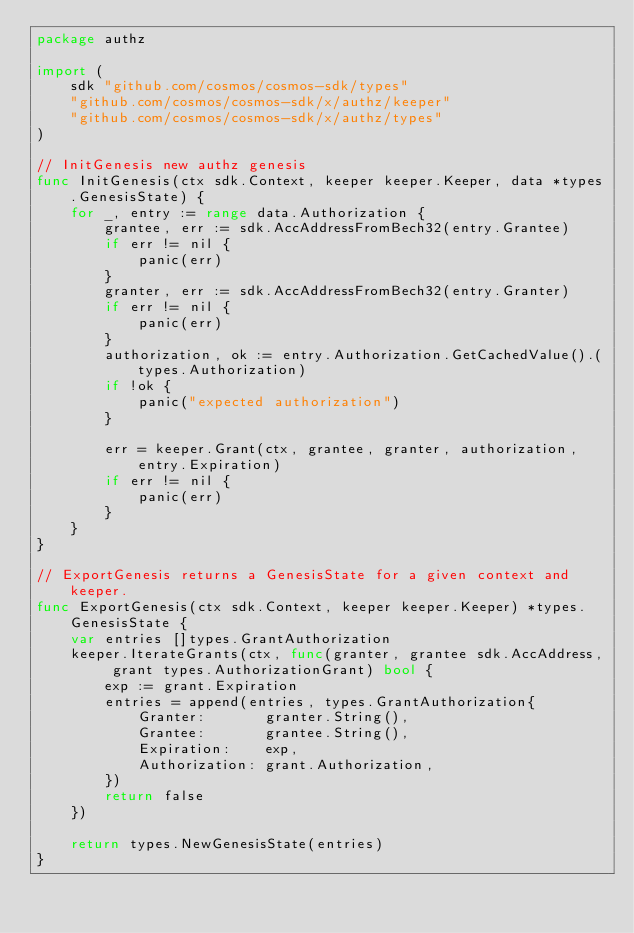<code> <loc_0><loc_0><loc_500><loc_500><_Go_>package authz

import (
	sdk "github.com/cosmos/cosmos-sdk/types"
	"github.com/cosmos/cosmos-sdk/x/authz/keeper"
	"github.com/cosmos/cosmos-sdk/x/authz/types"
)

// InitGenesis new authz genesis
func InitGenesis(ctx sdk.Context, keeper keeper.Keeper, data *types.GenesisState) {
	for _, entry := range data.Authorization {
		grantee, err := sdk.AccAddressFromBech32(entry.Grantee)
		if err != nil {
			panic(err)
		}
		granter, err := sdk.AccAddressFromBech32(entry.Granter)
		if err != nil {
			panic(err)
		}
		authorization, ok := entry.Authorization.GetCachedValue().(types.Authorization)
		if !ok {
			panic("expected authorization")
		}

		err = keeper.Grant(ctx, grantee, granter, authorization, entry.Expiration)
		if err != nil {
			panic(err)
		}
	}
}

// ExportGenesis returns a GenesisState for a given context and keeper.
func ExportGenesis(ctx sdk.Context, keeper keeper.Keeper) *types.GenesisState {
	var entries []types.GrantAuthorization
	keeper.IterateGrants(ctx, func(granter, grantee sdk.AccAddress, grant types.AuthorizationGrant) bool {
		exp := grant.Expiration
		entries = append(entries, types.GrantAuthorization{
			Granter:       granter.String(),
			Grantee:       grantee.String(),
			Expiration:    exp,
			Authorization: grant.Authorization,
		})
		return false
	})

	return types.NewGenesisState(entries)
}
</code> 